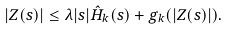<formula> <loc_0><loc_0><loc_500><loc_500>| Z ( s ) | \leq \lambda | s | \hat { H } _ { k } ( s ) + g _ { k } ( | Z ( s ) | ) .</formula> 